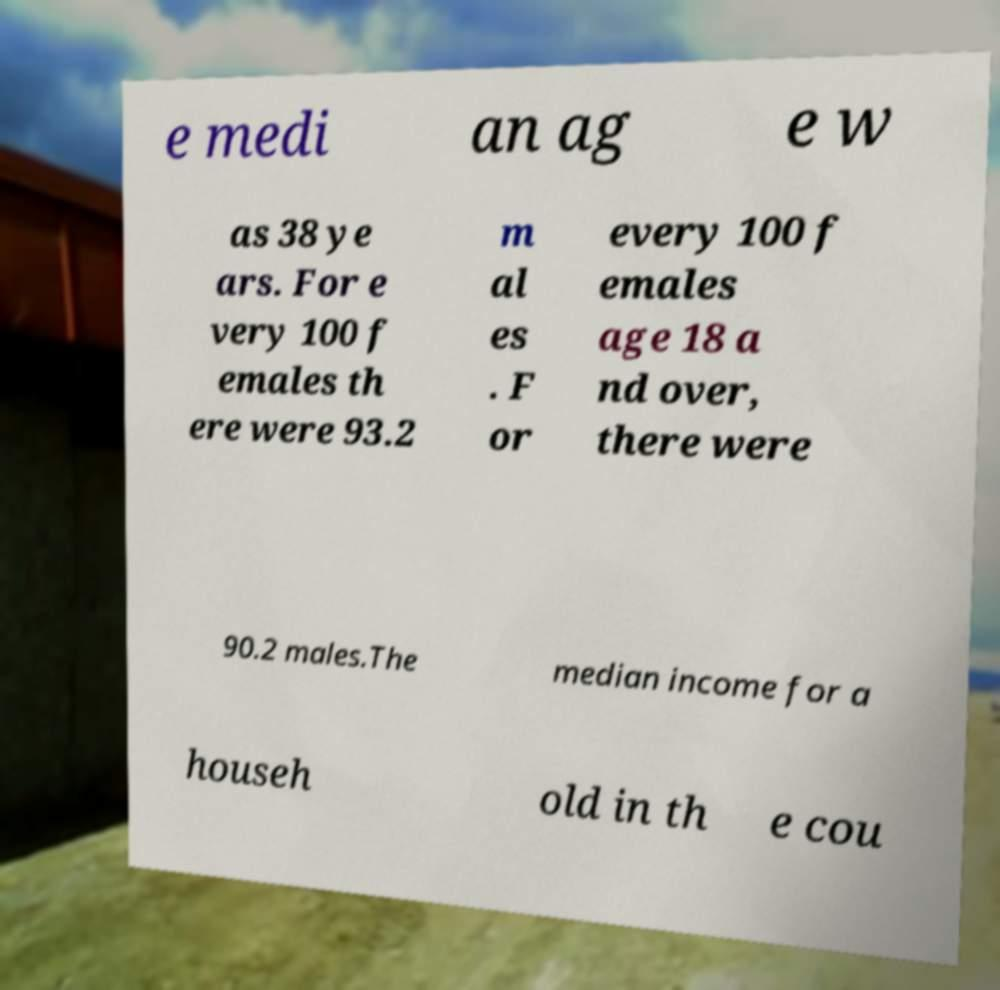There's text embedded in this image that I need extracted. Can you transcribe it verbatim? e medi an ag e w as 38 ye ars. For e very 100 f emales th ere were 93.2 m al es . F or every 100 f emales age 18 a nd over, there were 90.2 males.The median income for a househ old in th e cou 